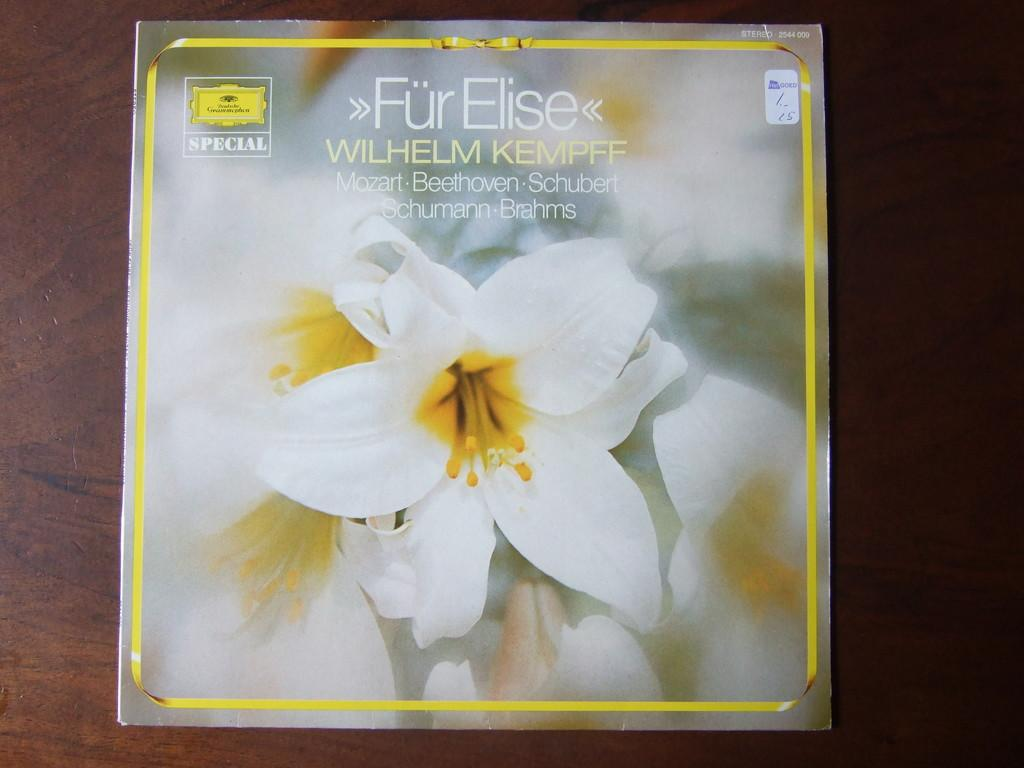What is the main object in the image? There is a card in the image. What is the card placed on? The card is on a wooden surface. What design is featured on the card? The card contains flowers. Can you describe the text at the top of the image? There is text at the top of the image, but its content is not specified in the provided facts. How many examples of lumber can be seen in the image? There is no lumber present in the image; the card is placed on a wooden surface, but that does not necessarily mean it is lumber. What is the height of the card in the image? The provided facts do not mention the height of the card, so it cannot be determined from the image. 